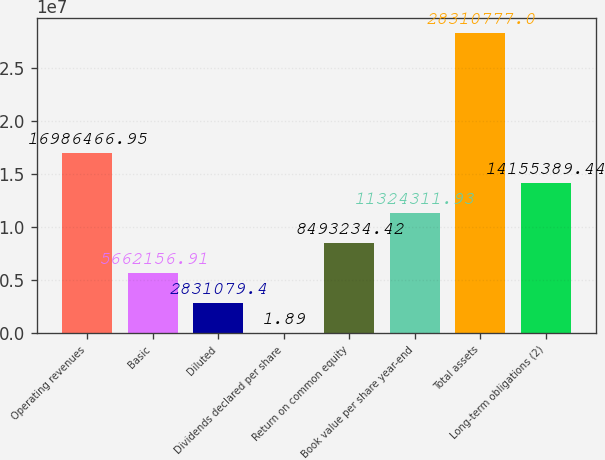<chart> <loc_0><loc_0><loc_500><loc_500><bar_chart><fcel>Operating revenues<fcel>Basic<fcel>Diluted<fcel>Dividends declared per share<fcel>Return on common equity<fcel>Book value per share year-end<fcel>Total assets<fcel>Long-term obligations (2)<nl><fcel>1.69865e+07<fcel>5.66216e+06<fcel>2.83108e+06<fcel>1.89<fcel>8.49323e+06<fcel>1.13243e+07<fcel>2.83108e+07<fcel>1.41554e+07<nl></chart> 